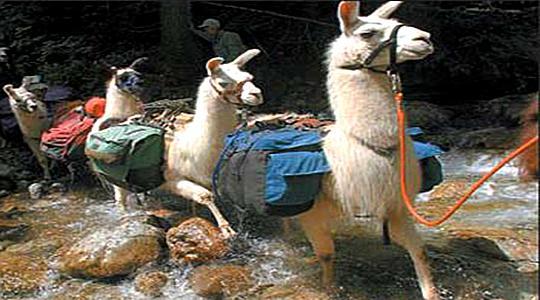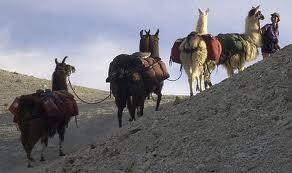The first image is the image on the left, the second image is the image on the right. Evaluate the accuracy of this statement regarding the images: "In at least one one image there is a single lama facing right with some white fur and a rope around its neck.". Is it true? Answer yes or no. No. The first image is the image on the left, the second image is the image on the right. Evaluate the accuracy of this statement regarding the images: "In one of the images, the animals are close to an automobile.". Is it true? Answer yes or no. No. 